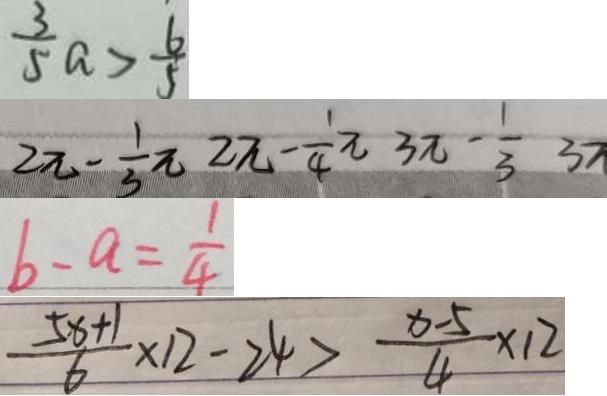Convert formula to latex. <formula><loc_0><loc_0><loc_500><loc_500>\frac { 3 } { 5 } a > \frac { 6 } { 5 } 
 2 \pi - \frac { 1 } { 3 } \pi 2 \pi - \frac { 1 } { 4 } \pi 3 \pi - \frac { 1 } { 3 } 3 \pi 
 b - a = \frac { 1 } { 4 } 
 \frac { 5 x + 1 } { 6 } \times 1 2 - 2 4 > \frac { x - 5 } { 4 } \times 1 2</formula> 